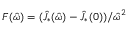<formula> <loc_0><loc_0><loc_500><loc_500>F ( \hat { \omega } ) = ( \hat { J } _ { * } ( \hat { \omega } ) - \hat { J } _ { * } ( 0 ) ) / \hat { \omega } ^ { 2 }</formula> 